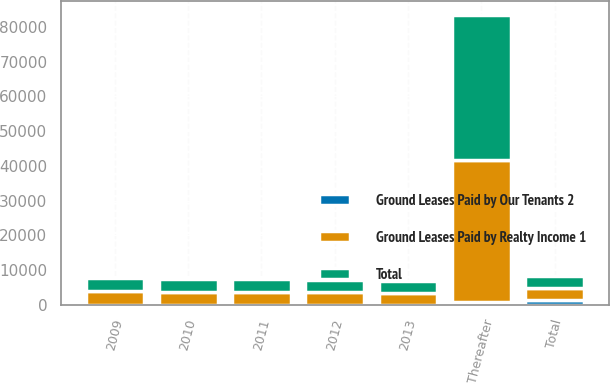Convert chart to OTSL. <chart><loc_0><loc_0><loc_500><loc_500><stacked_bar_chart><ecel><fcel>2009<fcel>2010<fcel>2011<fcel>2012<fcel>2013<fcel>Thereafter<fcel>Total<nl><fcel>Ground Leases Paid by Our Tenants 2<fcel>92<fcel>82<fcel>69<fcel>69<fcel>69<fcel>900<fcel>1281<nl><fcel>Ground Leases Paid by Realty Income 1<fcel>3791<fcel>3680<fcel>3667<fcel>3563<fcel>3420<fcel>40801<fcel>3563<nl><fcel>Total<fcel>3883<fcel>3762<fcel>3736<fcel>3632<fcel>3489<fcel>41701<fcel>3563<nl></chart> 